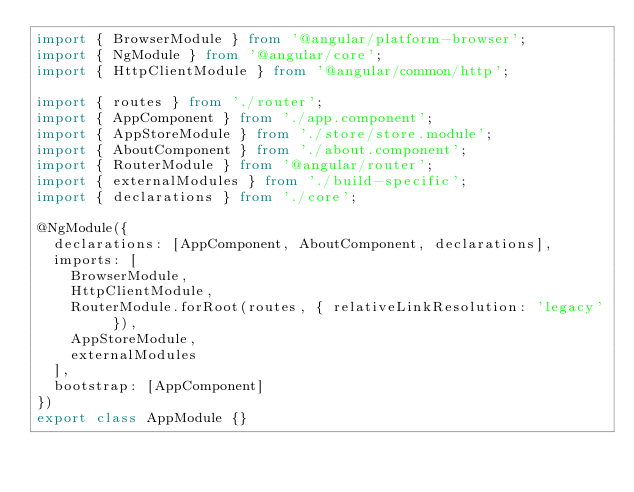Convert code to text. <code><loc_0><loc_0><loc_500><loc_500><_TypeScript_>import { BrowserModule } from '@angular/platform-browser';
import { NgModule } from '@angular/core';
import { HttpClientModule } from '@angular/common/http';

import { routes } from './router';
import { AppComponent } from './app.component';
import { AppStoreModule } from './store/store.module';
import { AboutComponent } from './about.component';
import { RouterModule } from '@angular/router';
import { externalModules } from './build-specific';
import { declarations } from './core';

@NgModule({
  declarations: [AppComponent, AboutComponent, declarations],
  imports: [
    BrowserModule,
    HttpClientModule,
    RouterModule.forRoot(routes, { relativeLinkResolution: 'legacy' }),
    AppStoreModule,
    externalModules
  ],
  bootstrap: [AppComponent]
})
export class AppModule {}
</code> 